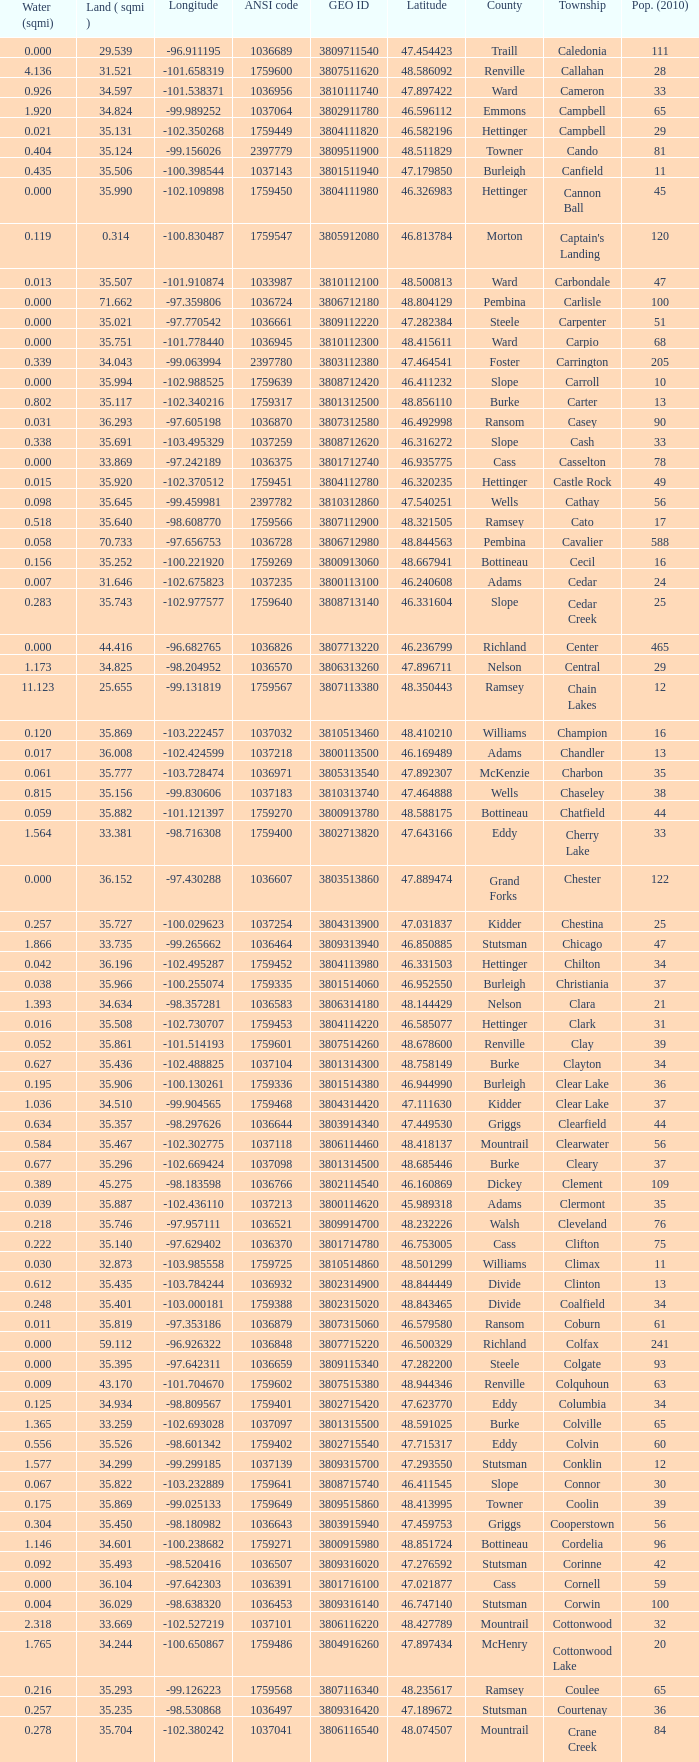What was the latitude of the Clearwater townsship? 48.418137. 